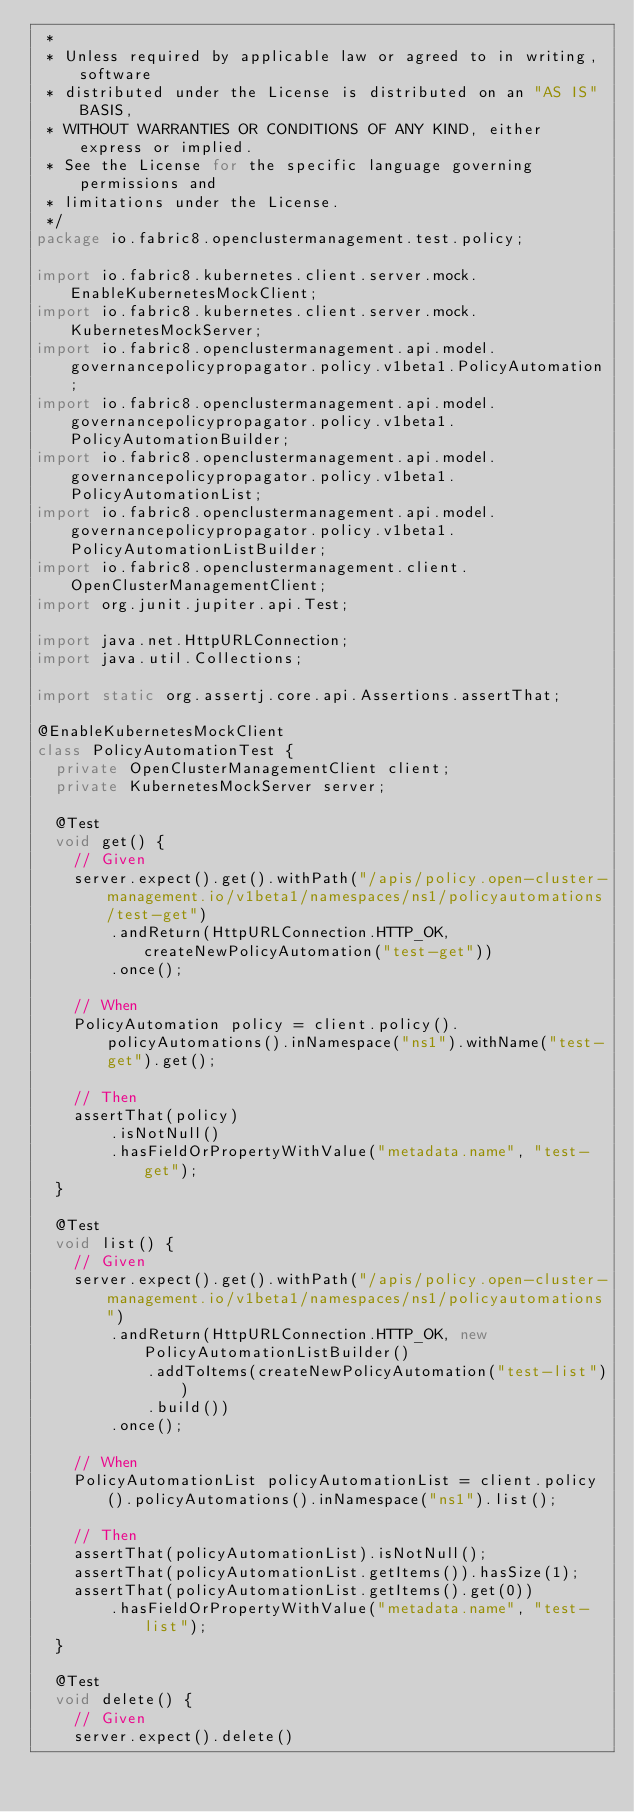Convert code to text. <code><loc_0><loc_0><loc_500><loc_500><_Java_> *
 * Unless required by applicable law or agreed to in writing, software
 * distributed under the License is distributed on an "AS IS" BASIS,
 * WITHOUT WARRANTIES OR CONDITIONS OF ANY KIND, either express or implied.
 * See the License for the specific language governing permissions and
 * limitations under the License.
 */
package io.fabric8.openclustermanagement.test.policy;

import io.fabric8.kubernetes.client.server.mock.EnableKubernetesMockClient;
import io.fabric8.kubernetes.client.server.mock.KubernetesMockServer;
import io.fabric8.openclustermanagement.api.model.governancepolicypropagator.policy.v1beta1.PolicyAutomation;
import io.fabric8.openclustermanagement.api.model.governancepolicypropagator.policy.v1beta1.PolicyAutomationBuilder;
import io.fabric8.openclustermanagement.api.model.governancepolicypropagator.policy.v1beta1.PolicyAutomationList;
import io.fabric8.openclustermanagement.api.model.governancepolicypropagator.policy.v1beta1.PolicyAutomationListBuilder;
import io.fabric8.openclustermanagement.client.OpenClusterManagementClient;
import org.junit.jupiter.api.Test;

import java.net.HttpURLConnection;
import java.util.Collections;

import static org.assertj.core.api.Assertions.assertThat;

@EnableKubernetesMockClient
class PolicyAutomationTest {
  private OpenClusterManagementClient client;
  private KubernetesMockServer server;

  @Test
  void get() {
    // Given
    server.expect().get().withPath("/apis/policy.open-cluster-management.io/v1beta1/namespaces/ns1/policyautomations/test-get")
        .andReturn(HttpURLConnection.HTTP_OK, createNewPolicyAutomation("test-get"))
        .once();

    // When
    PolicyAutomation policy = client.policy().policyAutomations().inNamespace("ns1").withName("test-get").get();

    // Then
    assertThat(policy)
        .isNotNull()
        .hasFieldOrPropertyWithValue("metadata.name", "test-get");
  }

  @Test
  void list() {
    // Given
    server.expect().get().withPath("/apis/policy.open-cluster-management.io/v1beta1/namespaces/ns1/policyautomations")
        .andReturn(HttpURLConnection.HTTP_OK, new PolicyAutomationListBuilder()
            .addToItems(createNewPolicyAutomation("test-list"))
            .build())
        .once();

    // When
    PolicyAutomationList policyAutomationList = client.policy().policyAutomations().inNamespace("ns1").list();

    // Then
    assertThat(policyAutomationList).isNotNull();
    assertThat(policyAutomationList.getItems()).hasSize(1);
    assertThat(policyAutomationList.getItems().get(0))
        .hasFieldOrPropertyWithValue("metadata.name", "test-list");
  }

  @Test
  void delete() {
    // Given
    server.expect().delete()</code> 